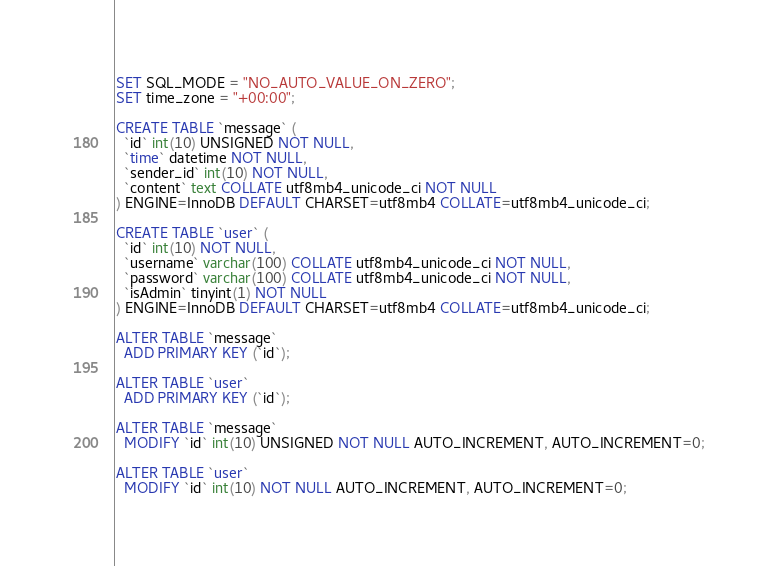Convert code to text. <code><loc_0><loc_0><loc_500><loc_500><_SQL_>SET SQL_MODE = "NO_AUTO_VALUE_ON_ZERO";
SET time_zone = "+00:00";

CREATE TABLE `message` (
  `id` int(10) UNSIGNED NOT NULL,
  `time` datetime NOT NULL,
  `sender_id` int(10) NOT NULL,
  `content` text COLLATE utf8mb4_unicode_ci NOT NULL
) ENGINE=InnoDB DEFAULT CHARSET=utf8mb4 COLLATE=utf8mb4_unicode_ci;

CREATE TABLE `user` (
  `id` int(10) NOT NULL,
  `username` varchar(100) COLLATE utf8mb4_unicode_ci NOT NULL,
  `password` varchar(100) COLLATE utf8mb4_unicode_ci NOT NULL,
  `isAdmin` tinyint(1) NOT NULL
) ENGINE=InnoDB DEFAULT CHARSET=utf8mb4 COLLATE=utf8mb4_unicode_ci;

ALTER TABLE `message`
  ADD PRIMARY KEY (`id`);

ALTER TABLE `user`
  ADD PRIMARY KEY (`id`);

ALTER TABLE `message`
  MODIFY `id` int(10) UNSIGNED NOT NULL AUTO_INCREMENT, AUTO_INCREMENT=0;

ALTER TABLE `user`
  MODIFY `id` int(10) NOT NULL AUTO_INCREMENT, AUTO_INCREMENT=0;
</code> 